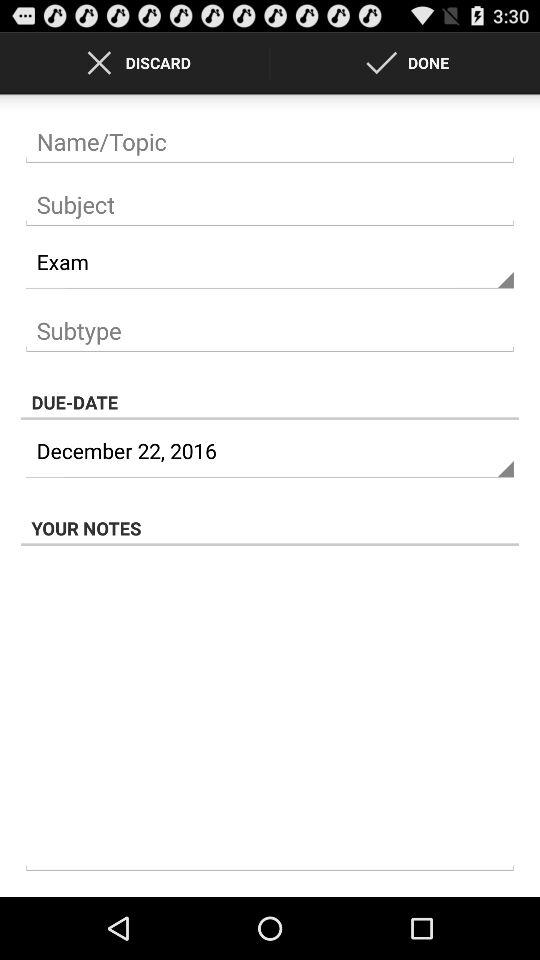What is the due date? The due date is December 22, 2016. 